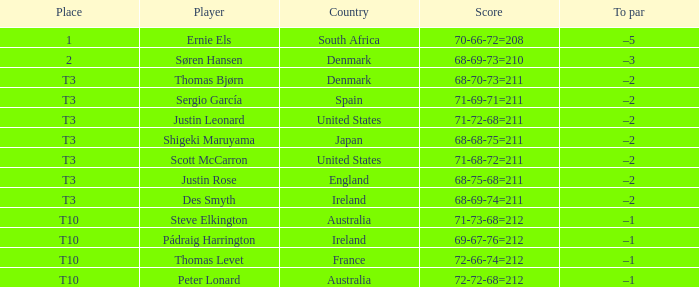When the scores were 71, 69, and 71, totaling 211, what was the ranking? T3. 